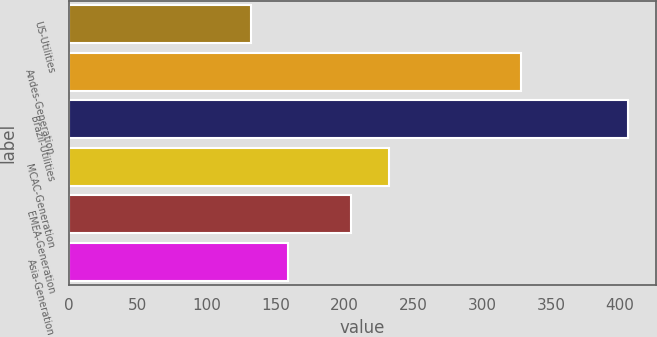Convert chart to OTSL. <chart><loc_0><loc_0><loc_500><loc_500><bar_chart><fcel>US-Utilities<fcel>Andes-Generation<fcel>Brazil-Utilities<fcel>MCAC-Generation<fcel>EMEA-Generation<fcel>Asia-Generation<nl><fcel>132<fcel>328<fcel>406<fcel>232.4<fcel>205<fcel>159.4<nl></chart> 